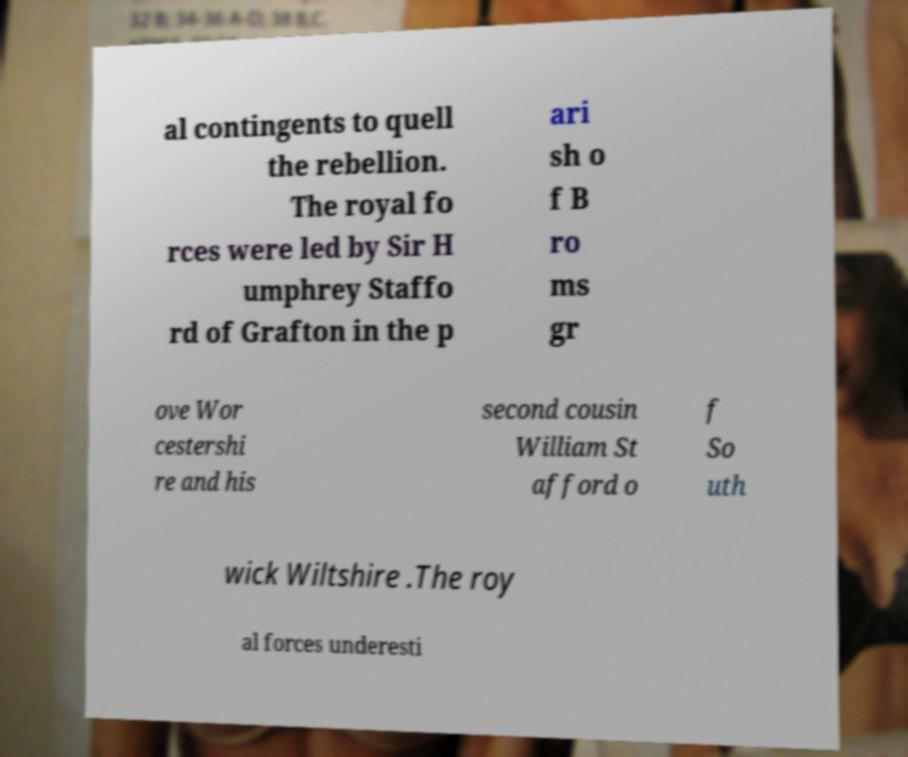Can you read and provide the text displayed in the image?This photo seems to have some interesting text. Can you extract and type it out for me? al contingents to quell the rebellion. The royal fo rces were led by Sir H umphrey Staffo rd of Grafton in the p ari sh o f B ro ms gr ove Wor cestershi re and his second cousin William St afford o f So uth wick Wiltshire .The roy al forces underesti 